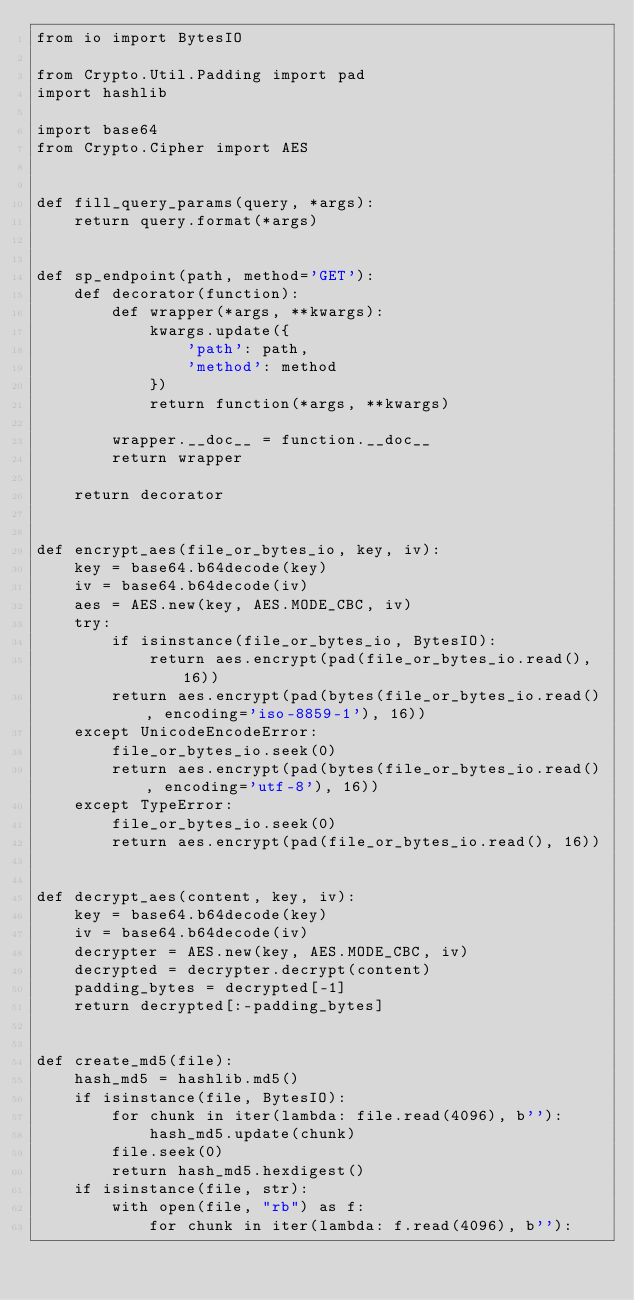Convert code to text. <code><loc_0><loc_0><loc_500><loc_500><_Python_>from io import BytesIO

from Crypto.Util.Padding import pad
import hashlib

import base64
from Crypto.Cipher import AES


def fill_query_params(query, *args):
    return query.format(*args)


def sp_endpoint(path, method='GET'):
    def decorator(function):
        def wrapper(*args, **kwargs):
            kwargs.update({
                'path': path,
                'method': method
            })
            return function(*args, **kwargs)

        wrapper.__doc__ = function.__doc__
        return wrapper

    return decorator


def encrypt_aes(file_or_bytes_io, key, iv):
    key = base64.b64decode(key)
    iv = base64.b64decode(iv)
    aes = AES.new(key, AES.MODE_CBC, iv)
    try:
        if isinstance(file_or_bytes_io, BytesIO):
            return aes.encrypt(pad(file_or_bytes_io.read(), 16))
        return aes.encrypt(pad(bytes(file_or_bytes_io.read(), encoding='iso-8859-1'), 16))
    except UnicodeEncodeError:
        file_or_bytes_io.seek(0)
        return aes.encrypt(pad(bytes(file_or_bytes_io.read(), encoding='utf-8'), 16))
    except TypeError:
        file_or_bytes_io.seek(0)
        return aes.encrypt(pad(file_or_bytes_io.read(), 16))


def decrypt_aes(content, key, iv):
    key = base64.b64decode(key)
    iv = base64.b64decode(iv)
    decrypter = AES.new(key, AES.MODE_CBC, iv)
    decrypted = decrypter.decrypt(content)
    padding_bytes = decrypted[-1]
    return decrypted[:-padding_bytes]


def create_md5(file):
    hash_md5 = hashlib.md5()
    if isinstance(file, BytesIO):
        for chunk in iter(lambda: file.read(4096), b''):
            hash_md5.update(chunk)
        file.seek(0)
        return hash_md5.hexdigest()
    if isinstance(file, str):
        with open(file, "rb") as f:
            for chunk in iter(lambda: f.read(4096), b''):</code> 